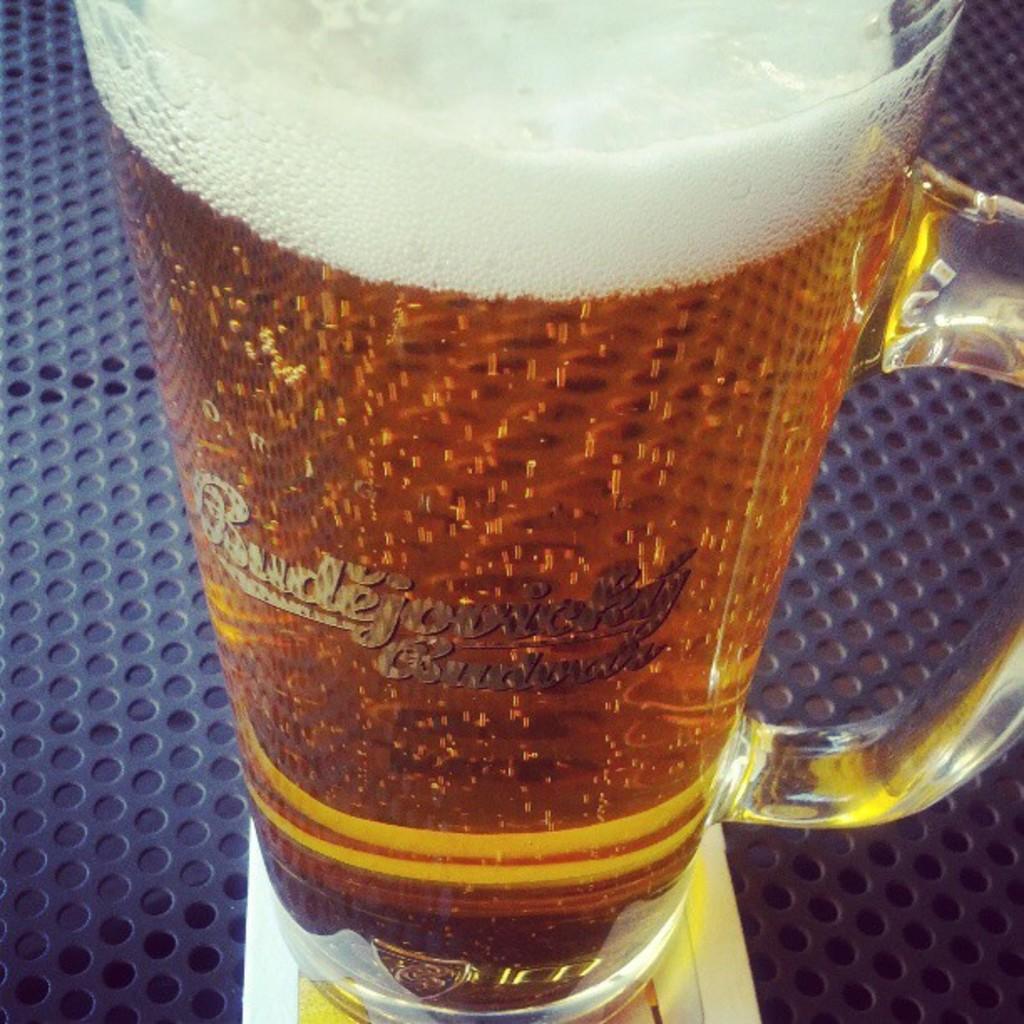What beer is this?
Give a very brief answer. Unanswerable. 